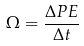Convert formula to latex. <formula><loc_0><loc_0><loc_500><loc_500>\Omega = \frac { \Delta P E } { \Delta t }</formula> 